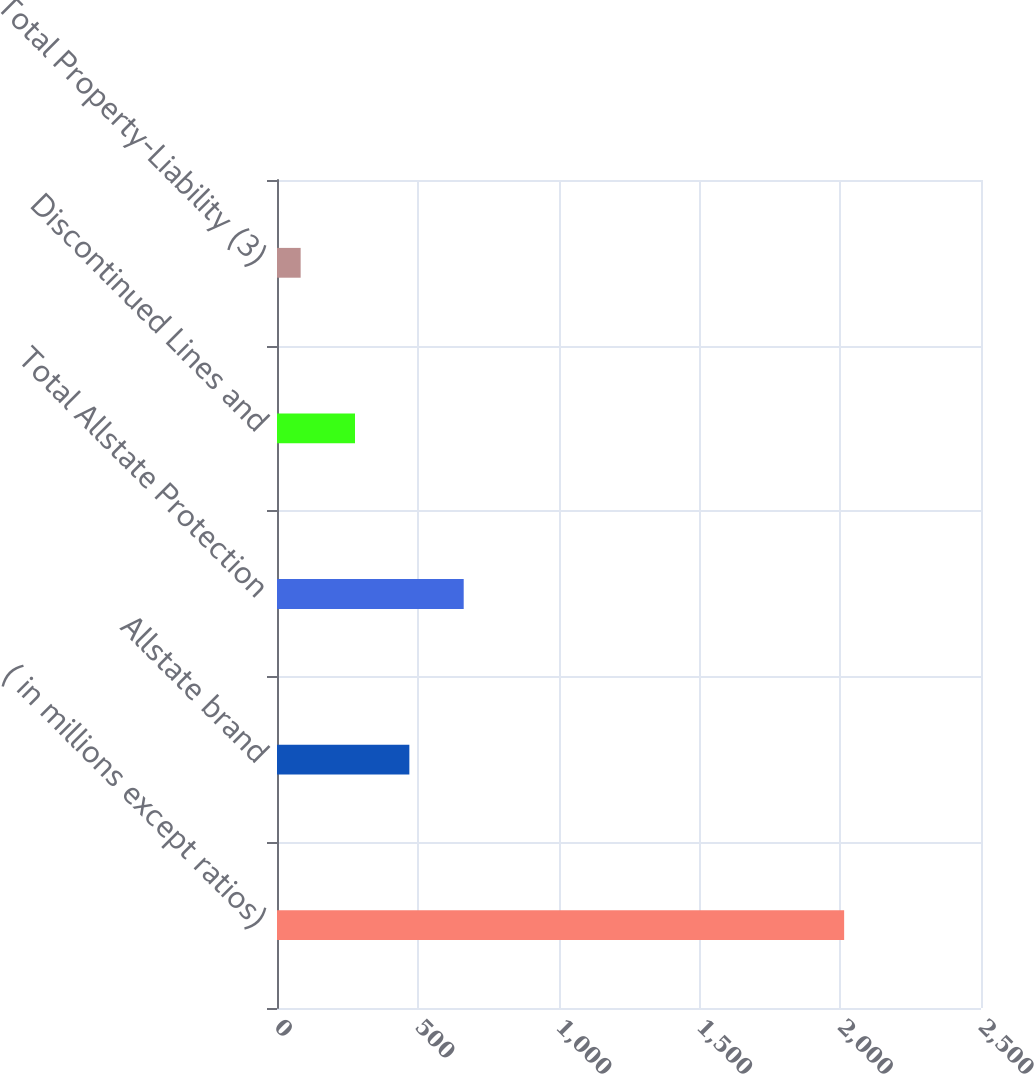<chart> <loc_0><loc_0><loc_500><loc_500><bar_chart><fcel>( in millions except ratios)<fcel>Allstate brand<fcel>Total Allstate Protection<fcel>Discontinued Lines and<fcel>Total Property-Liability (3)<nl><fcel>2014<fcel>470<fcel>663<fcel>277<fcel>84<nl></chart> 